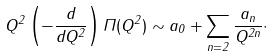<formula> <loc_0><loc_0><loc_500><loc_500>Q ^ { 2 } \left ( - \frac { d } { d Q ^ { 2 } } \right ) \Pi ( Q ^ { 2 } ) \sim a _ { 0 } + \sum _ { n = 2 } \frac { a _ { n } } { Q ^ { 2 n } } \cdot</formula> 